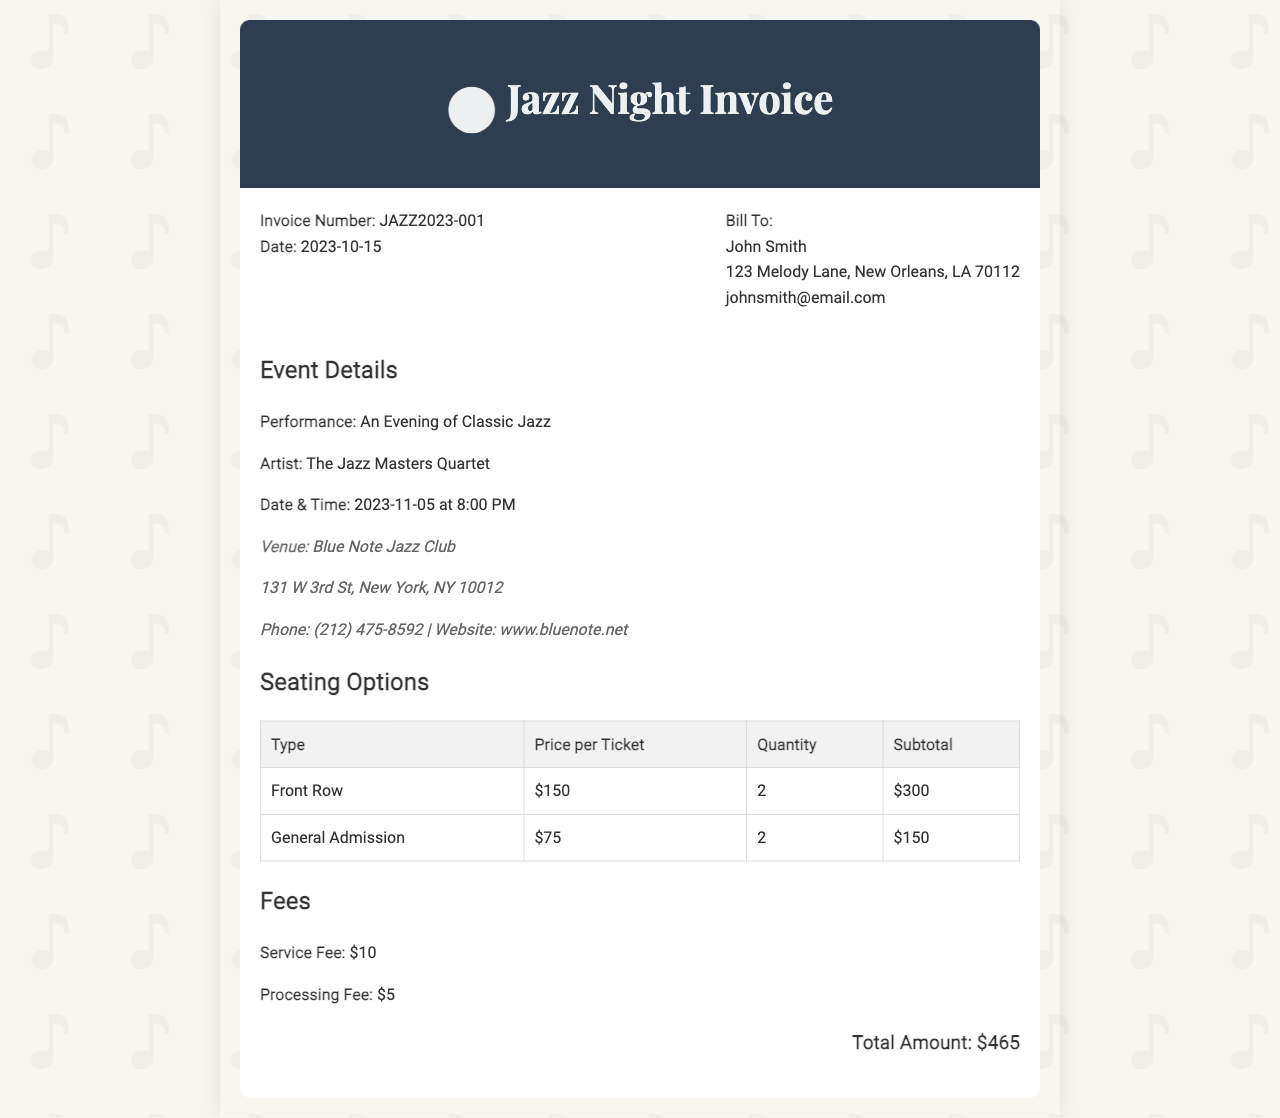What is the invoice number? The invoice number is a unique identifier for the invoice, which is JAZZ2023-001.
Answer: JAZZ2023-001 Who is the artist performing? The artist performing at the event is mentioned in the document as The Jazz Masters Quartet.
Answer: The Jazz Masters Quartet What is the date and time of the performance? The date and time of the performance can be found in the event details section, which states 2023-11-05 at 8:00 PM.
Answer: 2023-11-05 at 8:00 PM What is the subtotal for Front Row seating? The subtotal for Front Row seating is derived from the quantity and price per ticket listed, which is $300.
Answer: $300 What is the total amount? The total amount is the final figure of all charges in the invoice, noted as $465.
Answer: $465 What is the service fee? The document lists the service fee separately, which is $10.
Answer: $10 Where is the venue located? The venue location is provided in the venue information section, which states 131 W 3rd St, New York, NY 10012.
Answer: 131 W 3rd St, New York, NY 10012 How many tickets were purchased in total? The total number of tickets is the sum of the quantities of both seating options listed, which totals 4.
Answer: 4 What type of invoice is this? This document is specifically an invoice for tickets, typically given in a formal financial transaction context.
Answer: Invoice for tickets 